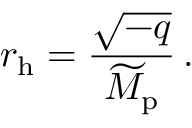<formula> <loc_0><loc_0><loc_500><loc_500>r _ { h } = { \frac { \sqrt { - q } } { \widetilde { M } _ { p } } } \, .</formula> 